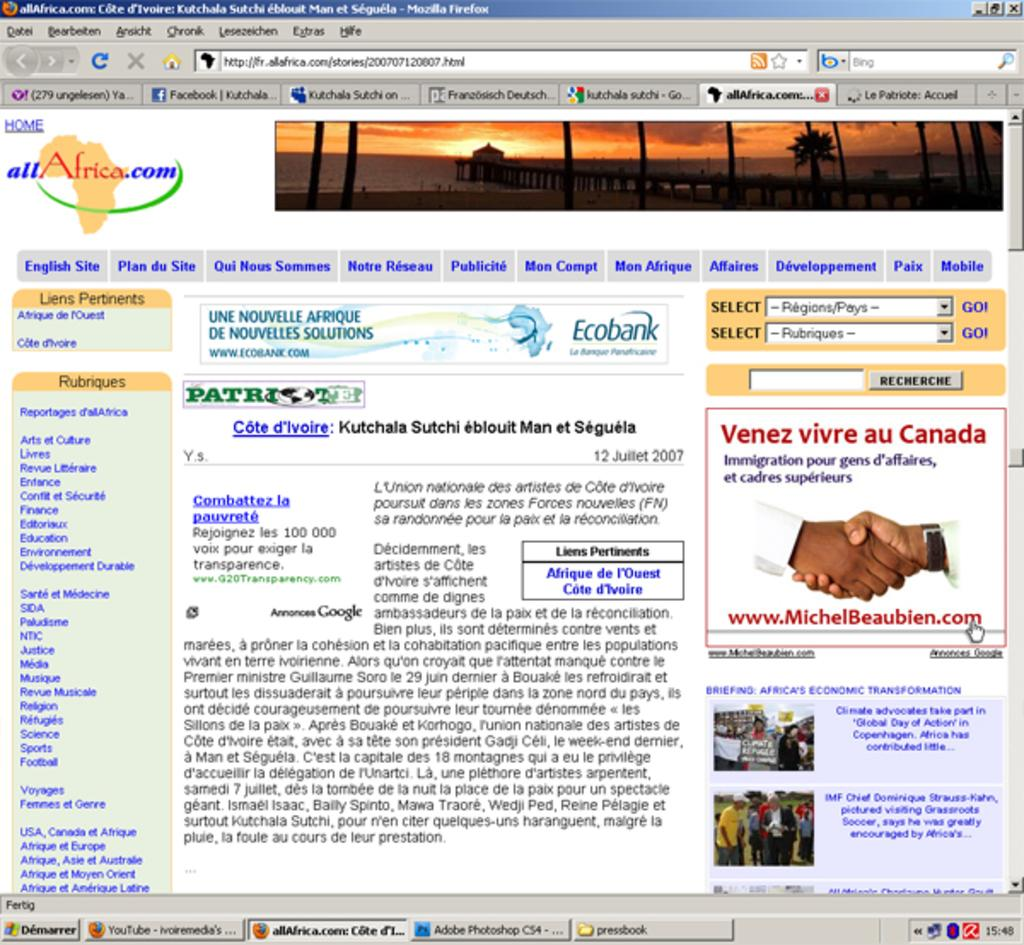What is the main subject of the poster in the image? The poster depicts the sky, clouds, trees, and people. What other objects are present on the poster? The poster contains other objects, but the specific details are not mentioned in the facts. Is there any text on the poster? Yes, there is text on the poster. Can you see a boat in the poster? No, there is no boat depicted in the poster. 